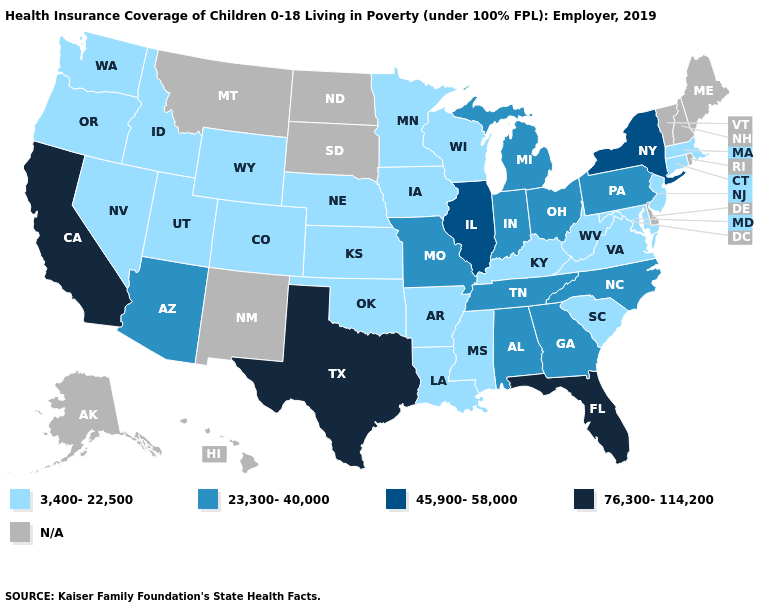Does California have the lowest value in the West?
Answer briefly. No. What is the value of Nevada?
Be succinct. 3,400-22,500. What is the value of North Carolina?
Keep it brief. 23,300-40,000. Which states hav the highest value in the South?
Quick response, please. Florida, Texas. Which states have the highest value in the USA?
Short answer required. California, Florida, Texas. What is the value of New Jersey?
Give a very brief answer. 3,400-22,500. Which states have the lowest value in the USA?
Quick response, please. Arkansas, Colorado, Connecticut, Idaho, Iowa, Kansas, Kentucky, Louisiana, Maryland, Massachusetts, Minnesota, Mississippi, Nebraska, Nevada, New Jersey, Oklahoma, Oregon, South Carolina, Utah, Virginia, Washington, West Virginia, Wisconsin, Wyoming. What is the value of Pennsylvania?
Be succinct. 23,300-40,000. What is the highest value in states that border Mississippi?
Write a very short answer. 23,300-40,000. What is the highest value in states that border Kansas?
Write a very short answer. 23,300-40,000. Name the states that have a value in the range 76,300-114,200?
Be succinct. California, Florida, Texas. Among the states that border Nevada , does Utah have the highest value?
Short answer required. No. Name the states that have a value in the range N/A?
Short answer required. Alaska, Delaware, Hawaii, Maine, Montana, New Hampshire, New Mexico, North Dakota, Rhode Island, South Dakota, Vermont. What is the value of Georgia?
Be succinct. 23,300-40,000. 